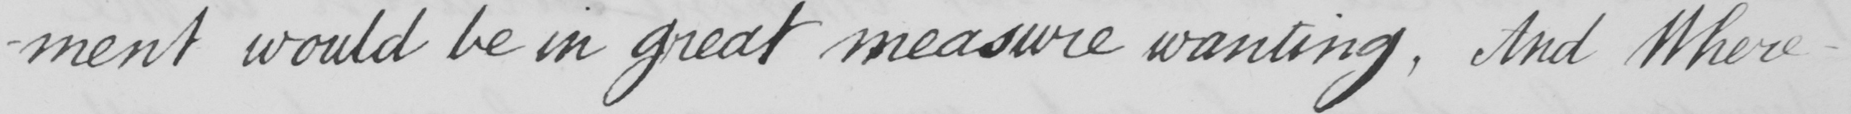What does this handwritten line say? -ment would be in great measure wanting , And Where- 